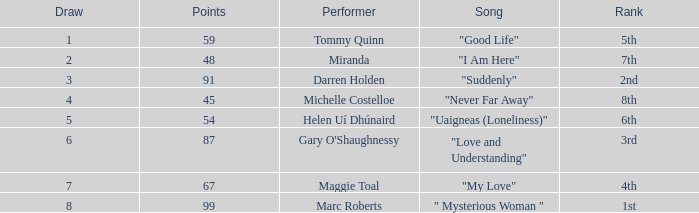What is the average number of points for a song ranked 2nd with a draw greater than 3? None. 